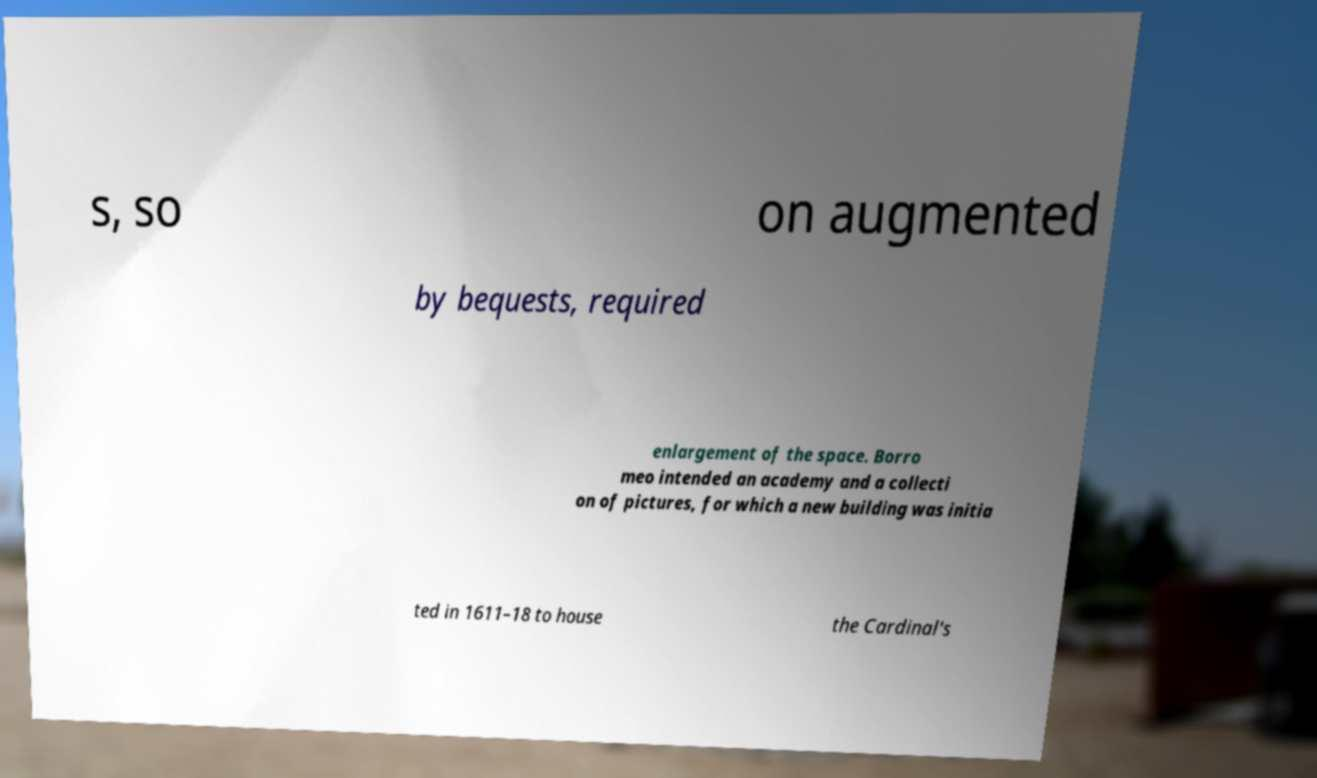Please read and relay the text visible in this image. What does it say? s, so on augmented by bequests, required enlargement of the space. Borro meo intended an academy and a collecti on of pictures, for which a new building was initia ted in 1611–18 to house the Cardinal's 